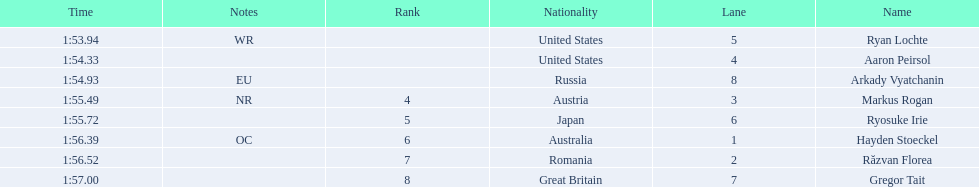Did austria or russia rank higher? Russia. 